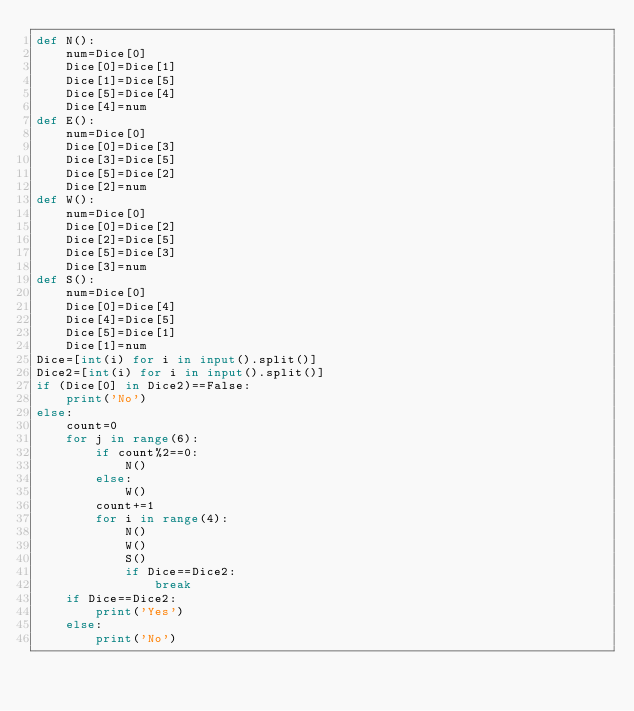<code> <loc_0><loc_0><loc_500><loc_500><_Python_>def N():
    num=Dice[0]
    Dice[0]=Dice[1]
    Dice[1]=Dice[5]
    Dice[5]=Dice[4]
    Dice[4]=num
def E():
    num=Dice[0]
    Dice[0]=Dice[3]
    Dice[3]=Dice[5]
    Dice[5]=Dice[2]
    Dice[2]=num
def W():
    num=Dice[0]
    Dice[0]=Dice[2]
    Dice[2]=Dice[5]
    Dice[5]=Dice[3]
    Dice[3]=num
def S():
    num=Dice[0]
    Dice[0]=Dice[4]
    Dice[4]=Dice[5]
    Dice[5]=Dice[1]
    Dice[1]=num
Dice=[int(i) for i in input().split()]
Dice2=[int(i) for i in input().split()]
if (Dice[0] in Dice2)==False:
    print('No')
else:
    count=0
    for j in range(6):
        if count%2==0:
            N()
        else:
            W()
        count+=1
        for i in range(4):
            N()
            W()
            S()
            if Dice==Dice2:
                break
    if Dice==Dice2:
        print('Yes')
    else:
        print('No')</code> 